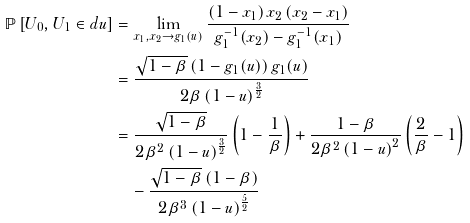<formula> <loc_0><loc_0><loc_500><loc_500>\mathbb { P } \left [ U _ { 0 } , U _ { 1 } \in d u \right ] & = \lim _ { x _ { 1 } , x _ { 2 } \rightarrow g _ { 1 } ( u ) } \frac { \left ( 1 - x _ { 1 } \right ) x _ { 2 } \left ( x _ { 2 } - x _ { 1 } \right ) } { g _ { 1 } ^ { - 1 } ( x _ { 2 } ) - g _ { 1 } ^ { - 1 } ( x _ { 1 } ) } \\ & = \frac { \sqrt { 1 - \beta } \left ( 1 - g _ { 1 } ( u ) \right ) g _ { 1 } ( u ) } { 2 \beta \left ( 1 - u \right ) ^ { \frac { 3 } { 2 } } } \\ & = \frac { \sqrt { 1 - \beta } } { 2 \beta ^ { 2 } \left ( 1 - u \right ) ^ { \frac { 3 } { 2 } } } \left ( 1 - \frac { 1 } { \beta } \right ) + \frac { 1 - \beta } { 2 \beta ^ { 2 } \left ( 1 - u \right ) ^ { 2 } } \left ( \frac { 2 } { \beta } - 1 \right ) \\ & \quad - \frac { \sqrt { 1 - \beta } \left ( 1 - \beta \right ) } { 2 \beta ^ { 3 } \left ( 1 - u \right ) ^ { \frac { 5 } { 2 } } }</formula> 